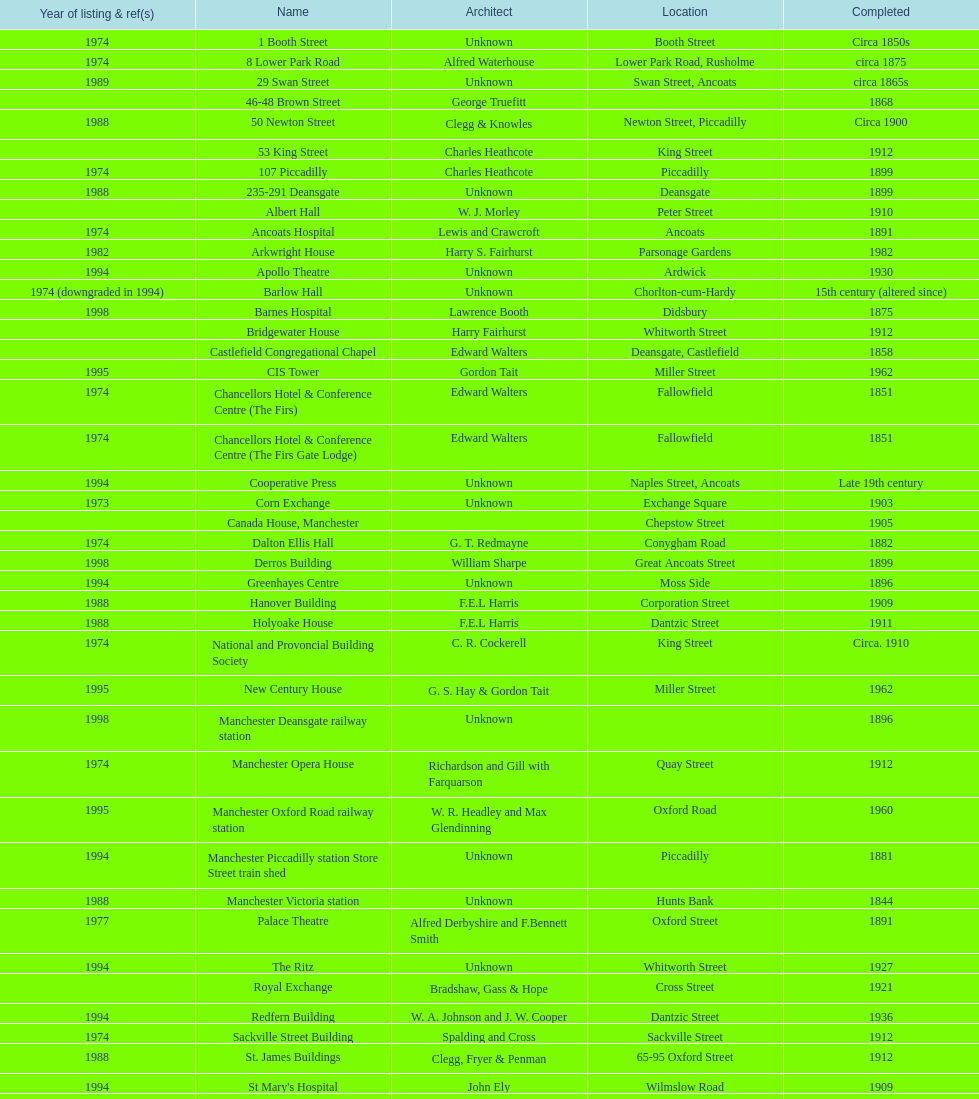Which two buildings were listed before 1974? The Old Wellington Inn, Smithfield Market Hall. 